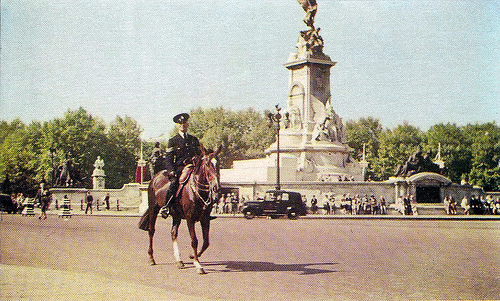What is the historical significance of the monument in the background? The monument in the background appears to be rich in historical significance. While I can't provide specific details without more information, such monuments are often erected to commemorate important national events, honor notable figures, or symbolize freedom and valor. To fully grasp its significance, one would need to know its location and the specific event or person it commemorates. 